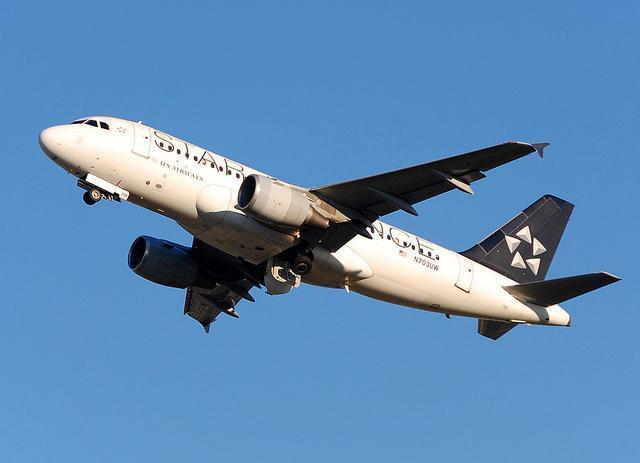How many jets does the plane have?
Give a very brief answer. 2. How many airplanes are there?
Give a very brief answer. 1. 